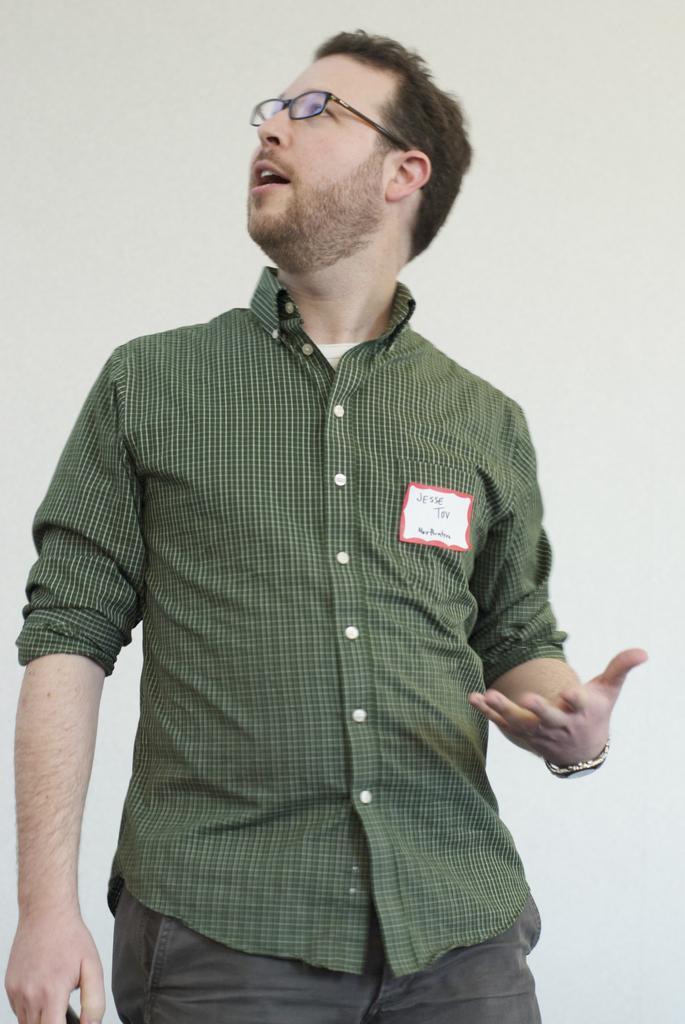Describe this image in one or two sentences. In the foreground of this image, there is a man standing in green color shirt. In the background, there is a wall. 